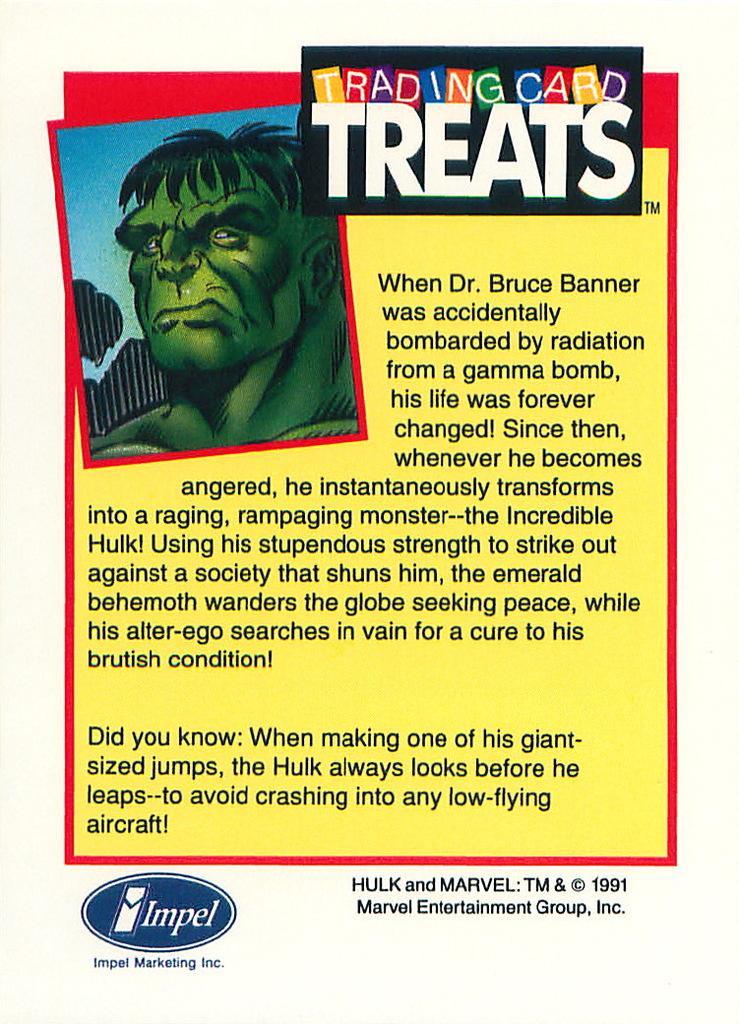Can you describe this image briefly? In this picture we can see a poster with an animated image and some information. 